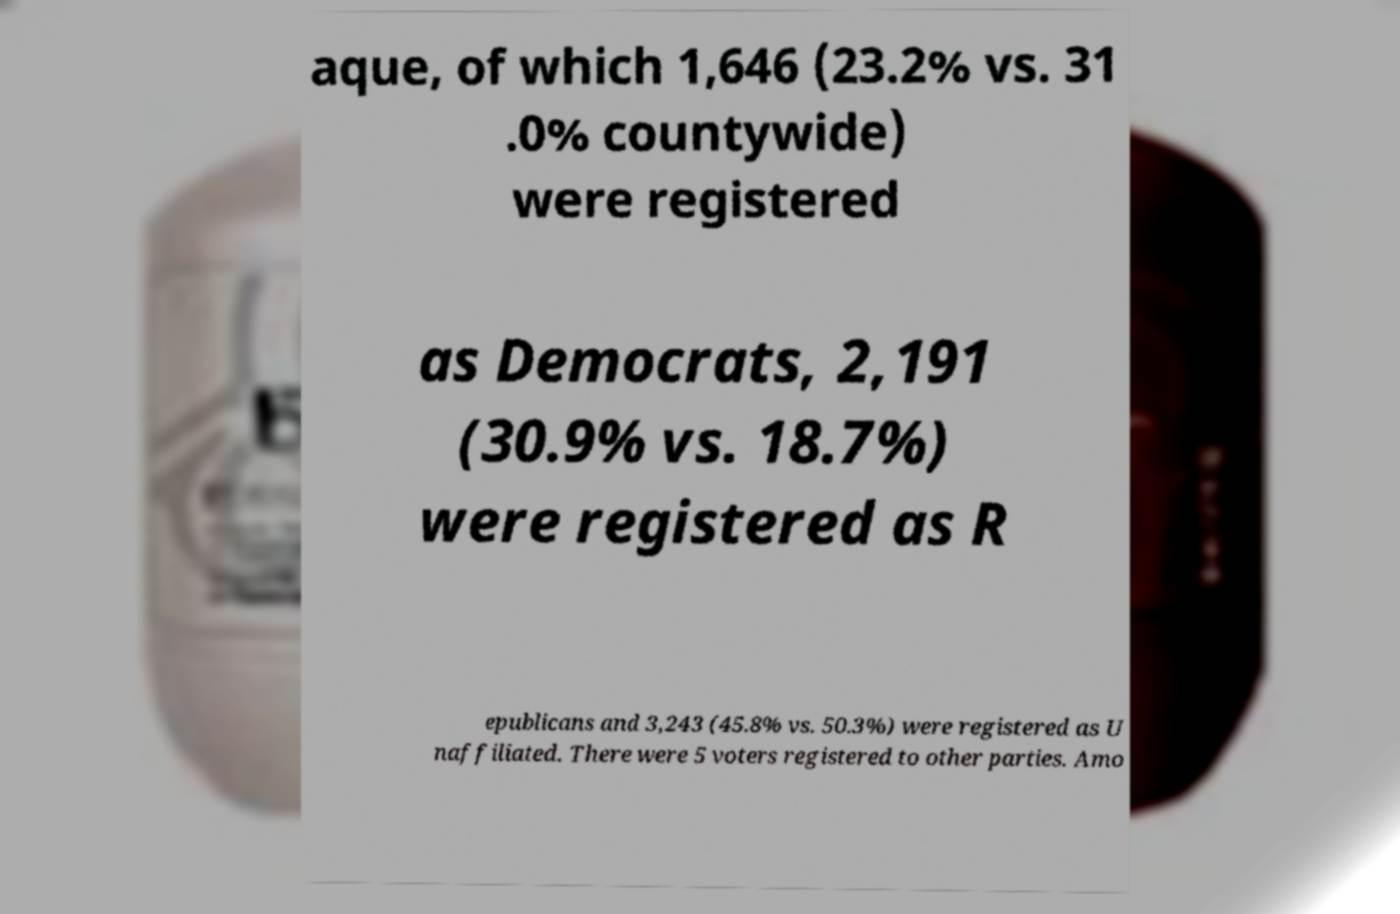Can you accurately transcribe the text from the provided image for me? aque, of which 1,646 (23.2% vs. 31 .0% countywide) were registered as Democrats, 2,191 (30.9% vs. 18.7%) were registered as R epublicans and 3,243 (45.8% vs. 50.3%) were registered as U naffiliated. There were 5 voters registered to other parties. Amo 